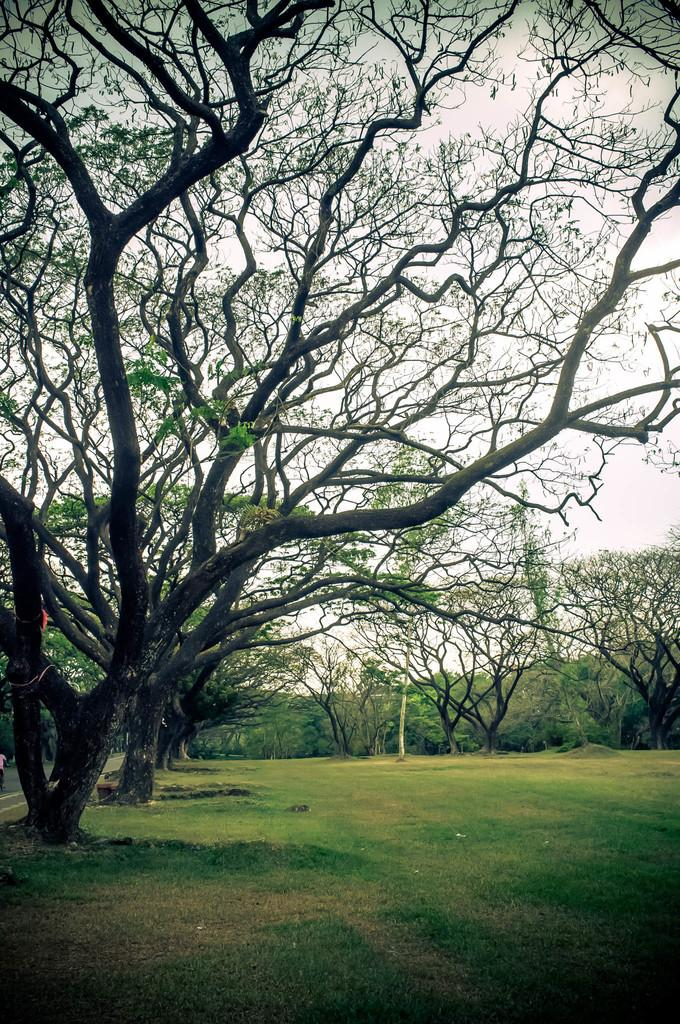What type of trees can be seen in the image? There are dried trees in the image. What can be seen in the background of the image? There are green trees in the background of the image. What is the color of the sky in the image? The sky is white in color. What is the purpose of the zinc in the image? There is no zinc present in the image, so it is not possible to determine its purpose. 